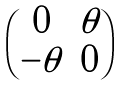Convert formula to latex. <formula><loc_0><loc_0><loc_500><loc_500>\begin{pmatrix} 0 & \theta \\ - \theta & 0 \end{pmatrix}</formula> 